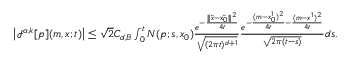<formula> <loc_0><loc_0><loc_500><loc_500>\begin{array} { r } { \left | { \mathcal { I } } ^ { \alpha , k } [ p ] ( m , x ; t ) \right | \leq \sqrt { 2 } C _ { d , B } \int _ { 0 } ^ { t } N ( p ; s , x _ { 0 } ) \frac { e ^ { - \frac { \| \tilde { x } - \tilde { x _ { 0 } } \| ^ { 2 } } { 4 t } } } { \sqrt { ( 2 \pi t ) ^ { d + 1 } } } \frac { e ^ { - \frac { ( m - x _ { 0 } ^ { 1 } ) ^ { 2 } } { 4 t } - \frac { ( m - x ^ { 1 } ) ^ { 2 } } { 4 t } } } { \sqrt { 2 \pi { ( t - s ) } } } d s . } \end{array}</formula> 